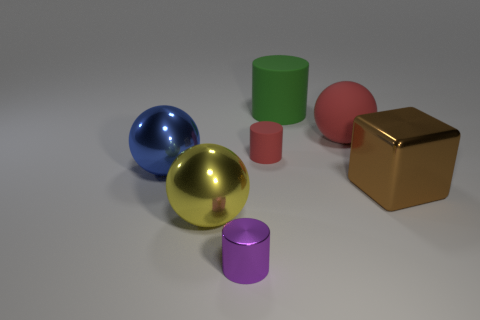There is a red matte object that is in front of the red rubber ball; is there a tiny red rubber thing on the left side of it? no 